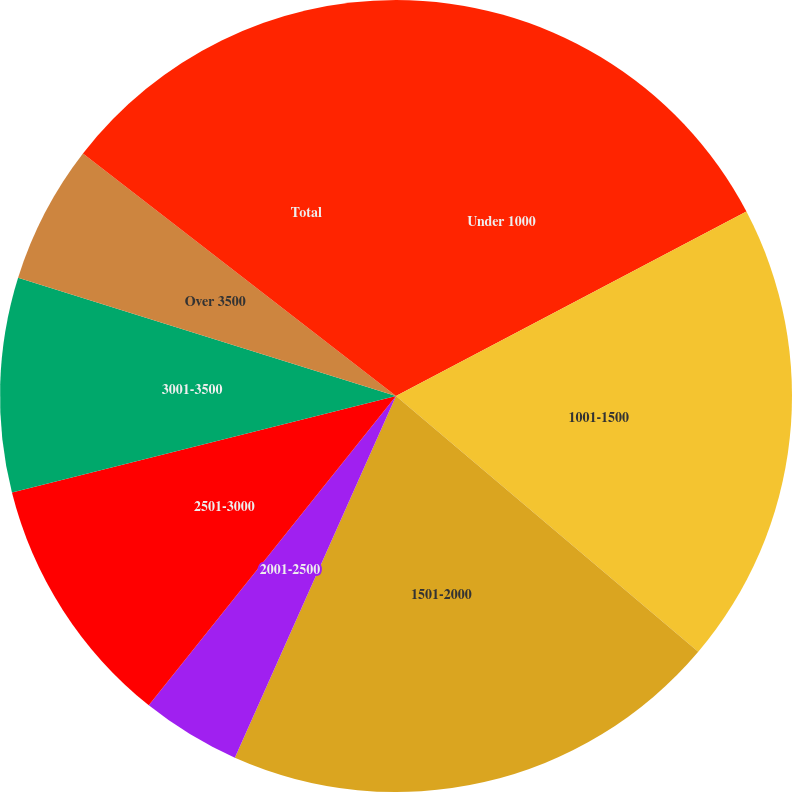<chart> <loc_0><loc_0><loc_500><loc_500><pie_chart><fcel>Under 1000<fcel>1001-1500<fcel>1501-2000<fcel>2001-2500<fcel>2501-3000<fcel>3001-3500<fcel>Over 3500<fcel>Total<nl><fcel>17.29%<fcel>18.89%<fcel>20.49%<fcel>4.06%<fcel>10.35%<fcel>8.75%<fcel>5.66%<fcel>14.51%<nl></chart> 